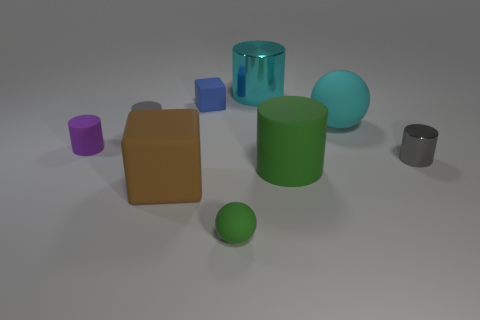The big shiny thing that is the same shape as the small purple object is what color?
Offer a terse response. Cyan. How many objects are tiny purple metallic things or rubber spheres in front of the big cyan cylinder?
Provide a short and direct response. 2. Are there fewer rubber cubes in front of the big brown matte object than green shiny objects?
Your answer should be compact. No. What is the size of the metallic cylinder that is to the left of the big rubber thing that is behind the gray object that is on the right side of the green rubber sphere?
Provide a succinct answer. Large. There is a tiny matte thing that is on the right side of the large rubber cube and in front of the blue matte block; what color is it?
Give a very brief answer. Green. What number of tiny red metal things are there?
Your response must be concise. 0. Do the small ball and the large ball have the same material?
Keep it short and to the point. Yes. There is a brown cube that is to the right of the small purple matte cylinder; is its size the same as the block behind the large ball?
Your answer should be compact. No. Is the number of red rubber blocks less than the number of big cyan matte spheres?
Provide a short and direct response. Yes. What number of shiny things are either large cyan objects or cylinders?
Offer a very short reply. 2. 